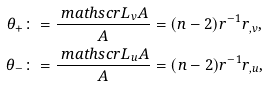Convert formula to latex. <formula><loc_0><loc_0><loc_500><loc_500>\theta _ { + } & \colon = \frac { { \ m a t h s c r L } _ { v } A } { A } = ( n - 2 ) r ^ { - 1 } r _ { , v } , \\ \theta _ { - } & \colon = \frac { { \ m a t h s c r L } _ { u } A } { A } = ( n - 2 ) r ^ { - 1 } r _ { , u } ,</formula> 